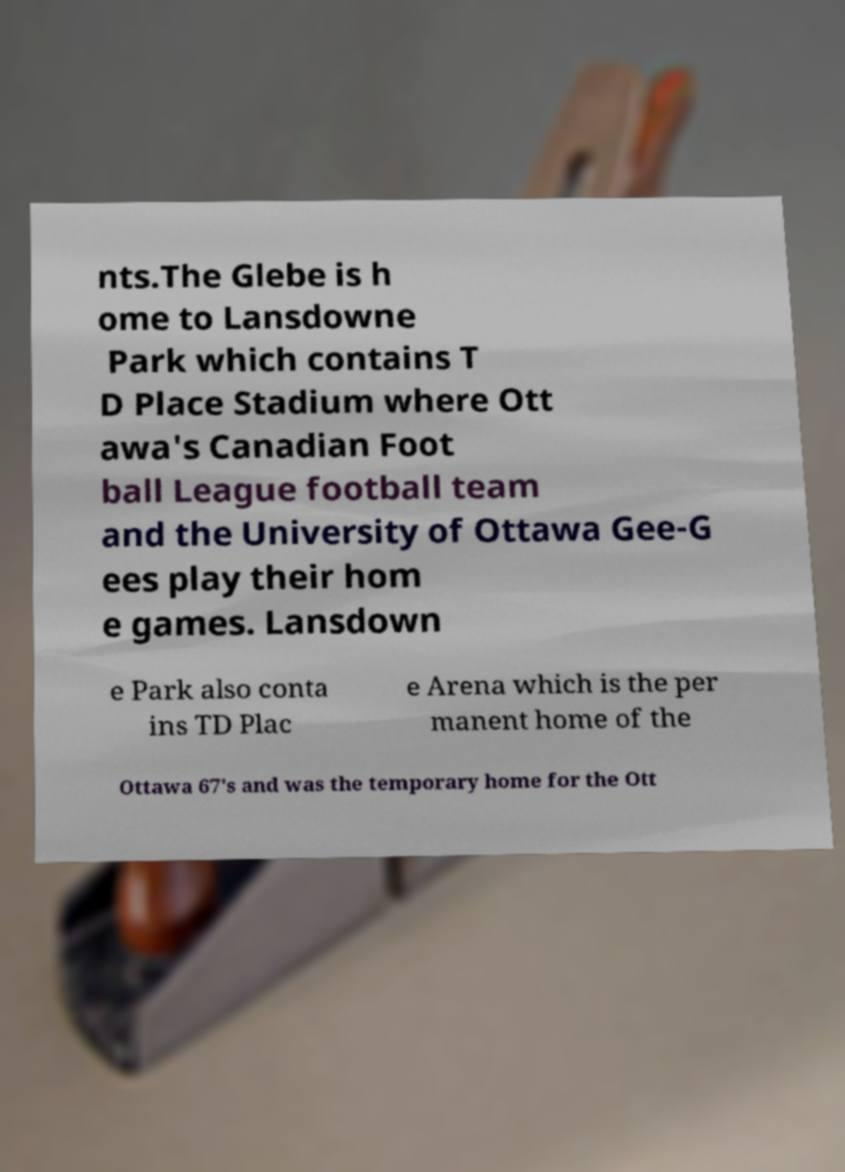What messages or text are displayed in this image? I need them in a readable, typed format. nts.The Glebe is h ome to Lansdowne Park which contains T D Place Stadium where Ott awa's Canadian Foot ball League football team and the University of Ottawa Gee-G ees play their hom e games. Lansdown e Park also conta ins TD Plac e Arena which is the per manent home of the Ottawa 67's and was the temporary home for the Ott 